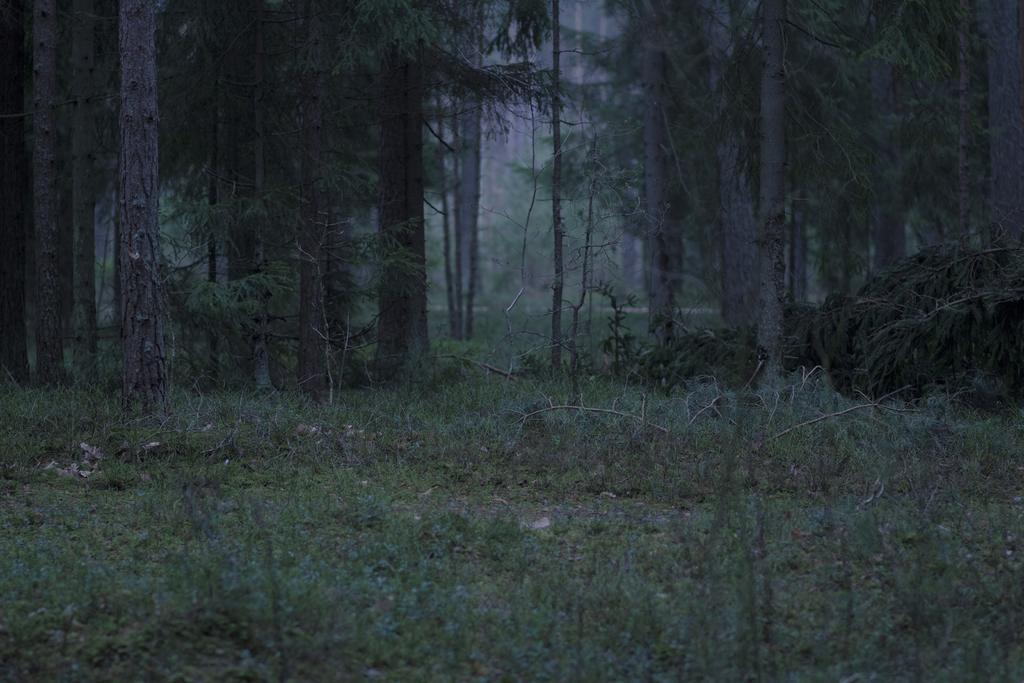Could you give a brief overview of what you see in this image? This image consists of many trees. At the bottom, there is green grass. It looks like a forest. 